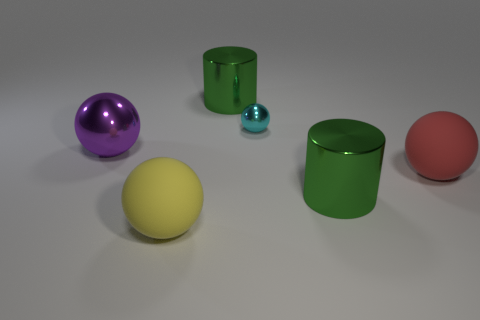Subtract 1 balls. How many balls are left? 3 Add 2 big purple blocks. How many objects exist? 8 Subtract all cylinders. How many objects are left? 4 Add 3 small spheres. How many small spheres are left? 4 Add 5 tiny shiny spheres. How many tiny shiny spheres exist? 6 Subtract 1 red spheres. How many objects are left? 5 Subtract all cyan metallic balls. Subtract all yellow rubber spheres. How many objects are left? 4 